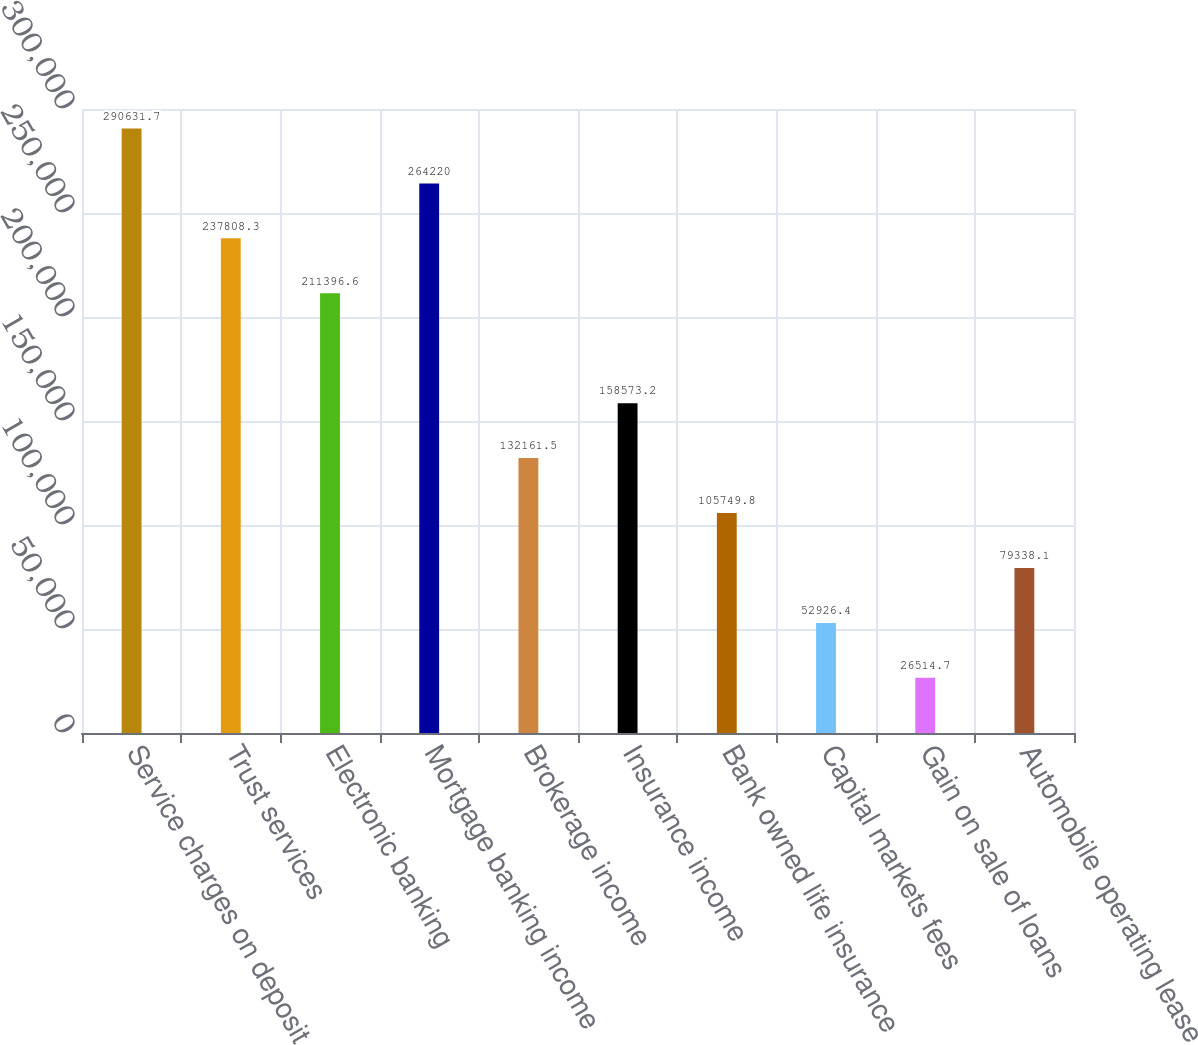<chart> <loc_0><loc_0><loc_500><loc_500><bar_chart><fcel>Service charges on deposit<fcel>Trust services<fcel>Electronic banking<fcel>Mortgage banking income<fcel>Brokerage income<fcel>Insurance income<fcel>Bank owned life insurance<fcel>Capital markets fees<fcel>Gain on sale of loans<fcel>Automobile operating lease<nl><fcel>290632<fcel>237808<fcel>211397<fcel>264220<fcel>132162<fcel>158573<fcel>105750<fcel>52926.4<fcel>26514.7<fcel>79338.1<nl></chart> 